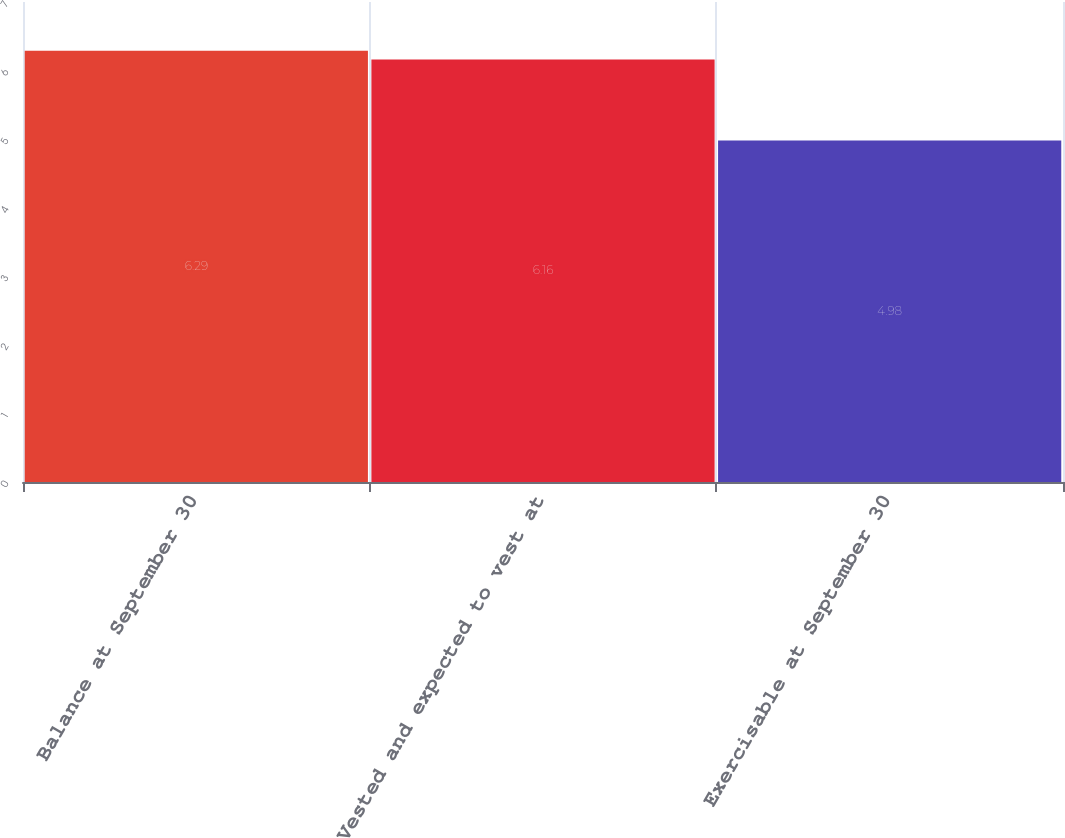Convert chart to OTSL. <chart><loc_0><loc_0><loc_500><loc_500><bar_chart><fcel>Balance at September 30<fcel>Vested and expected to vest at<fcel>Exercisable at September 30<nl><fcel>6.29<fcel>6.16<fcel>4.98<nl></chart> 